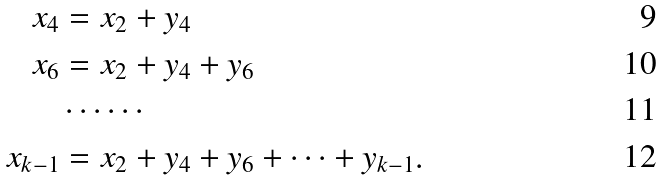<formula> <loc_0><loc_0><loc_500><loc_500>x _ { 4 } & = x _ { 2 } + y _ { 4 } \\ x _ { 6 } & = x _ { 2 } + y _ { 4 } + y _ { 6 } \\ & \cdots \cdots \\ x _ { k - 1 } & = x _ { 2 } + y _ { 4 } + y _ { 6 } + \cdots + y _ { k - 1 } .</formula> 